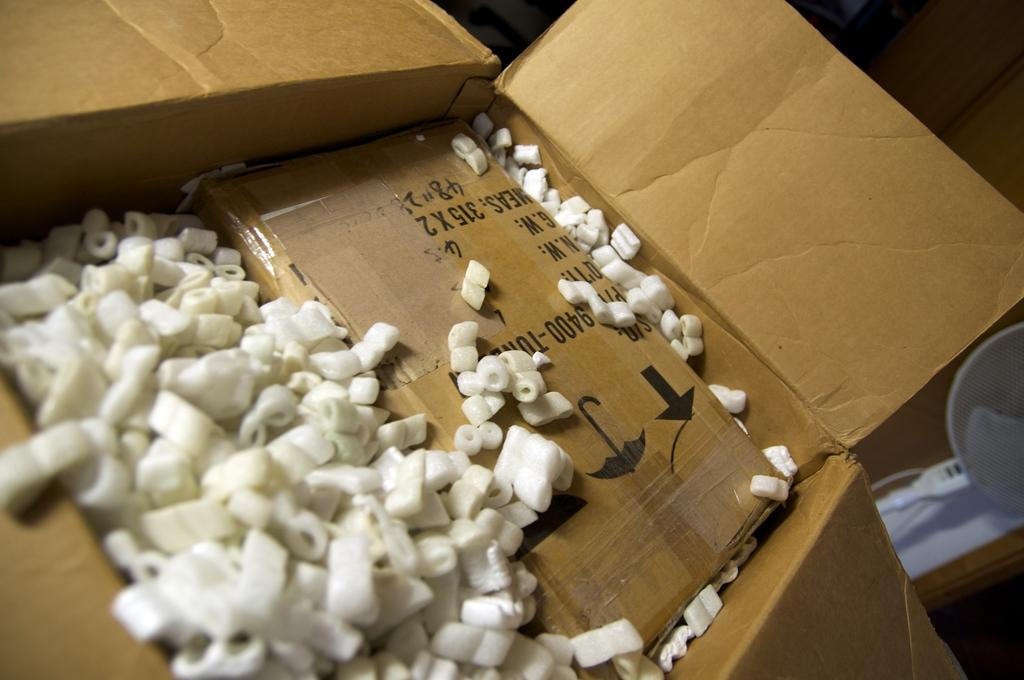What is inside the box in the image? There are white objects in a box. Can you describe the white object on the right side of the image? There is a white object on the right side of the image. What type of dress is the baby wearing in the image? There is no baby or dress present in the image; it only features white objects in a box and a white object on the right side. How many patches can be seen on the white object in the image? There are no patches visible on the white object in the image. 